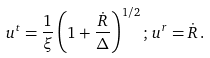<formula> <loc_0><loc_0><loc_500><loc_500>u ^ { t } = \frac { 1 } { \xi } \left ( 1 + \frac { \dot { R } } { \Delta } \right ) ^ { 1 / 2 } ; \, u ^ { r } = \dot { R } \, .</formula> 